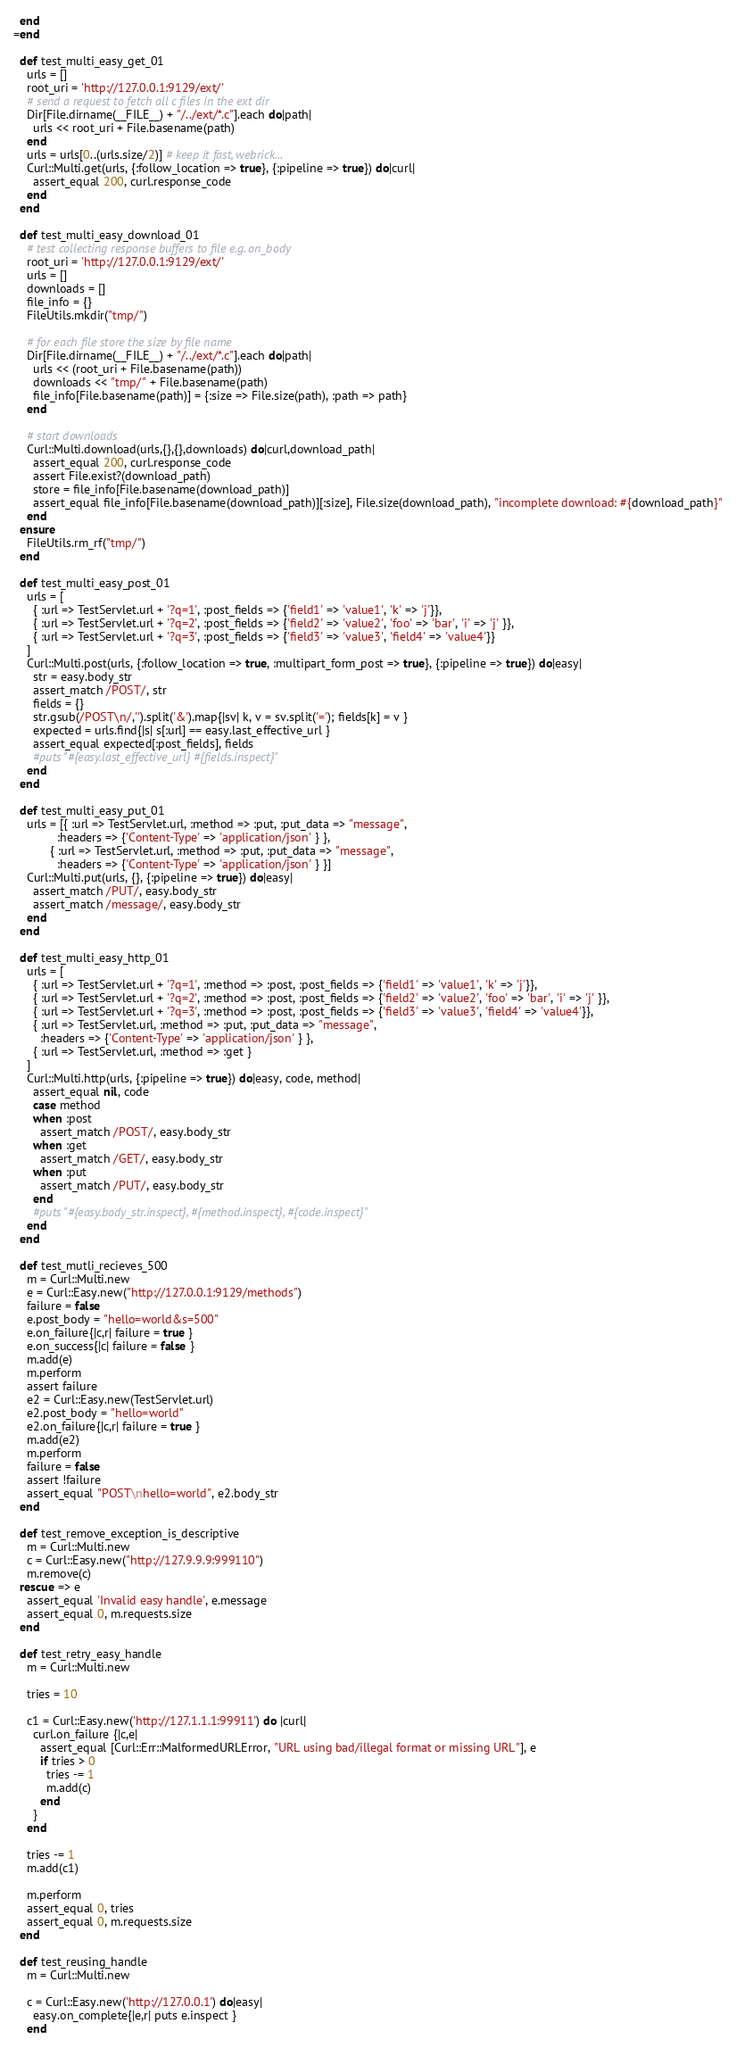<code> <loc_0><loc_0><loc_500><loc_500><_Ruby_>  end
=end

  def test_multi_easy_get_01
    urls = []
    root_uri = 'http://127.0.0.1:9129/ext/'
    # send a request to fetch all c files in the ext dir
    Dir[File.dirname(__FILE__) + "/../ext/*.c"].each do|path|
      urls << root_uri + File.basename(path)
    end
    urls = urls[0..(urls.size/2)] # keep it fast, webrick...
    Curl::Multi.get(urls, {:follow_location => true}, {:pipeline => true}) do|curl|
      assert_equal 200, curl.response_code
    end
  end

  def test_multi_easy_download_01
    # test collecting response buffers to file e.g. on_body
    root_uri = 'http://127.0.0.1:9129/ext/'
    urls = []
    downloads = []
    file_info = {}
    FileUtils.mkdir("tmp/")

    # for each file store the size by file name
    Dir[File.dirname(__FILE__) + "/../ext/*.c"].each do|path|
      urls << (root_uri + File.basename(path))
      downloads << "tmp/" + File.basename(path)
      file_info[File.basename(path)] = {:size => File.size(path), :path => path}
    end

    # start downloads
    Curl::Multi.download(urls,{},{},downloads) do|curl,download_path|
      assert_equal 200, curl.response_code
      assert File.exist?(download_path)
      store = file_info[File.basename(download_path)]
      assert_equal file_info[File.basename(download_path)][:size], File.size(download_path), "incomplete download: #{download_path}"
    end
  ensure
    FileUtils.rm_rf("tmp/")
  end

  def test_multi_easy_post_01
    urls = [
      { :url => TestServlet.url + '?q=1', :post_fields => {'field1' => 'value1', 'k' => 'j'}},
      { :url => TestServlet.url + '?q=2', :post_fields => {'field2' => 'value2', 'foo' => 'bar', 'i' => 'j' }},
      { :url => TestServlet.url + '?q=3', :post_fields => {'field3' => 'value3', 'field4' => 'value4'}}
    ]
    Curl::Multi.post(urls, {:follow_location => true, :multipart_form_post => true}, {:pipeline => true}) do|easy|
      str = easy.body_str
      assert_match /POST/, str
      fields = {}
      str.gsub(/POST\n/,'').split('&').map{|sv| k, v = sv.split('='); fields[k] = v }
      expected = urls.find{|s| s[:url] == easy.last_effective_url }
      assert_equal expected[:post_fields], fields
      #puts "#{easy.last_effective_url} #{fields.inspect}"
    end
  end

  def test_multi_easy_put_01
    urls = [{ :url => TestServlet.url, :method => :put, :put_data => "message",
             :headers => {'Content-Type' => 'application/json' } },
           { :url => TestServlet.url, :method => :put, :put_data => "message",
             :headers => {'Content-Type' => 'application/json' } }]
    Curl::Multi.put(urls, {}, {:pipeline => true}) do|easy|
      assert_match /PUT/, easy.body_str
      assert_match /message/, easy.body_str
    end
  end

  def test_multi_easy_http_01
    urls = [
      { :url => TestServlet.url + '?q=1', :method => :post, :post_fields => {'field1' => 'value1', 'k' => 'j'}},
      { :url => TestServlet.url + '?q=2', :method => :post, :post_fields => {'field2' => 'value2', 'foo' => 'bar', 'i' => 'j' }},
      { :url => TestServlet.url + '?q=3', :method => :post, :post_fields => {'field3' => 'value3', 'field4' => 'value4'}},
      { :url => TestServlet.url, :method => :put, :put_data => "message",
        :headers => {'Content-Type' => 'application/json' } },
      { :url => TestServlet.url, :method => :get }
    ]
    Curl::Multi.http(urls, {:pipeline => true}) do|easy, code, method|
      assert_equal nil, code
      case method
      when :post
        assert_match /POST/, easy.body_str
      when :get
        assert_match /GET/, easy.body_str
      when :put
        assert_match /PUT/, easy.body_str
      end
      #puts "#{easy.body_str.inspect}, #{method.inspect}, #{code.inspect}"
    end
  end

  def test_mutli_recieves_500
    m = Curl::Multi.new
    e = Curl::Easy.new("http://127.0.0.1:9129/methods")
    failure = false
    e.post_body = "hello=world&s=500"
    e.on_failure{|c,r| failure = true }
    e.on_success{|c| failure = false }
    m.add(e)
    m.perform
    assert failure
    e2 = Curl::Easy.new(TestServlet.url)
    e2.post_body = "hello=world"
    e2.on_failure{|c,r| failure = true }
    m.add(e2)
    m.perform
    failure = false
    assert !failure
    assert_equal "POST\nhello=world", e2.body_str
  end

  def test_remove_exception_is_descriptive
    m = Curl::Multi.new
    c = Curl::Easy.new("http://127.9.9.9:999110")
    m.remove(c)
  rescue => e
    assert_equal 'Invalid easy handle', e.message
    assert_equal 0, m.requests.size
  end

  def test_retry_easy_handle
    m = Curl::Multi.new

    tries = 10

    c1 = Curl::Easy.new('http://127.1.1.1:99911') do |curl|
      curl.on_failure {|c,e|
        assert_equal [Curl::Err::MalformedURLError, "URL using bad/illegal format or missing URL"], e
        if tries > 0
          tries -= 1
          m.add(c)
        end
      }
    end

    tries -= 1
    m.add(c1)

    m.perform
    assert_equal 0, tries
    assert_equal 0, m.requests.size
  end

  def test_reusing_handle
    m = Curl::Multi.new

    c = Curl::Easy.new('http://127.0.0.1') do|easy|
      easy.on_complete{|e,r| puts e.inspect }
    end
</code> 